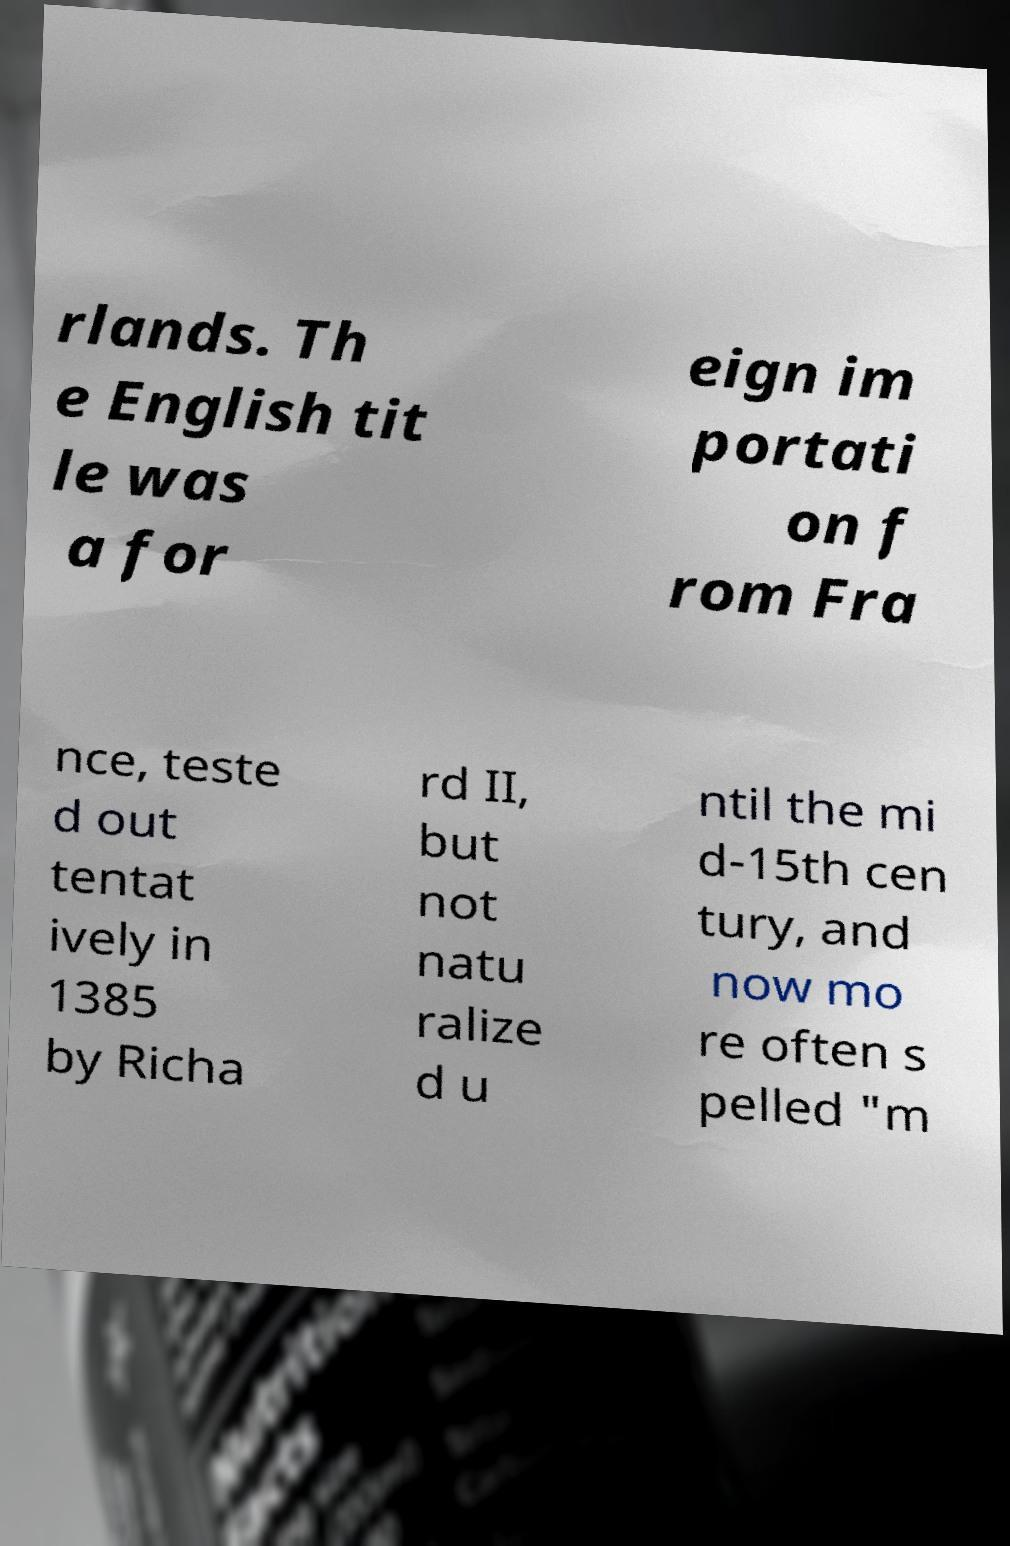What messages or text are displayed in this image? I need them in a readable, typed format. rlands. Th e English tit le was a for eign im portati on f rom Fra nce, teste d out tentat ively in 1385 by Richa rd II, but not natu ralize d u ntil the mi d-15th cen tury, and now mo re often s pelled "m 